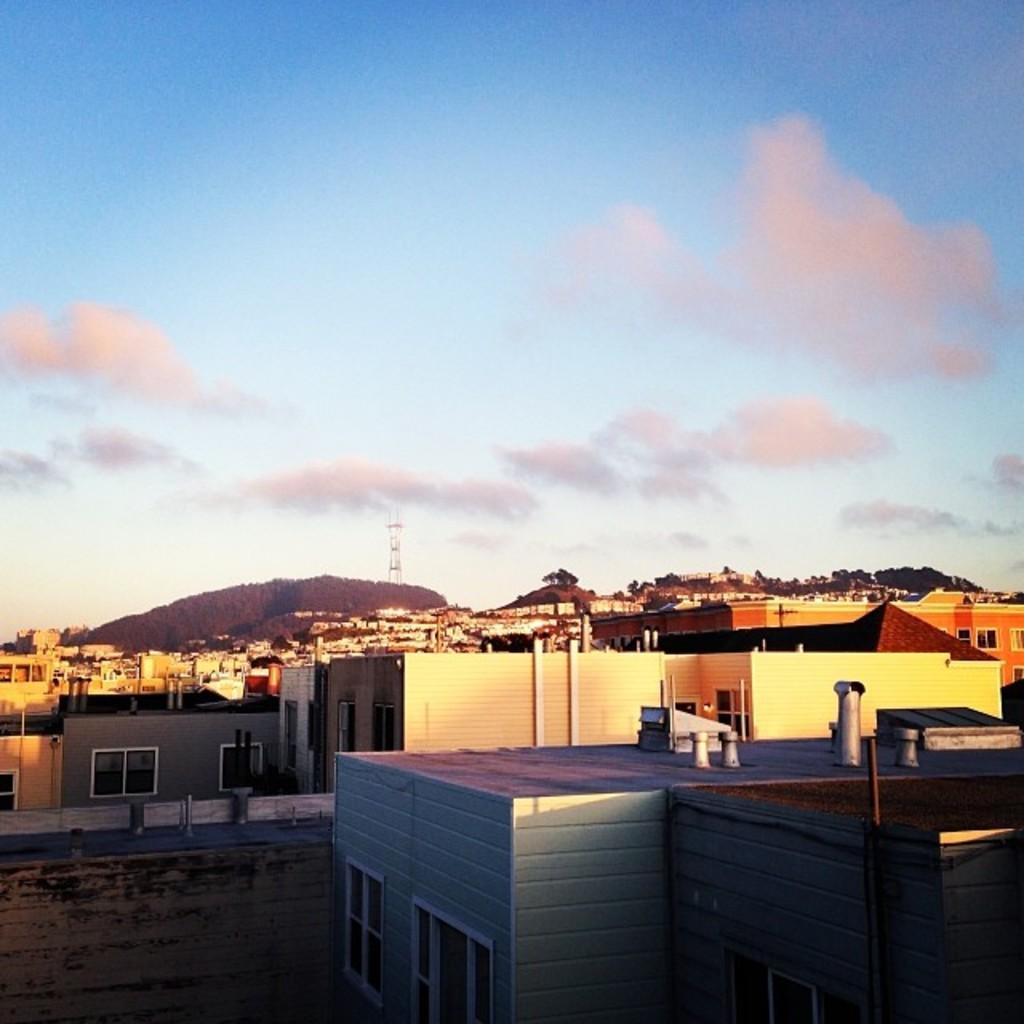In one or two sentences, can you explain what this image depicts? There are buildings, trees, a mountain, a tower and water on the ground. In the background, there are clouds in the blue sky. 